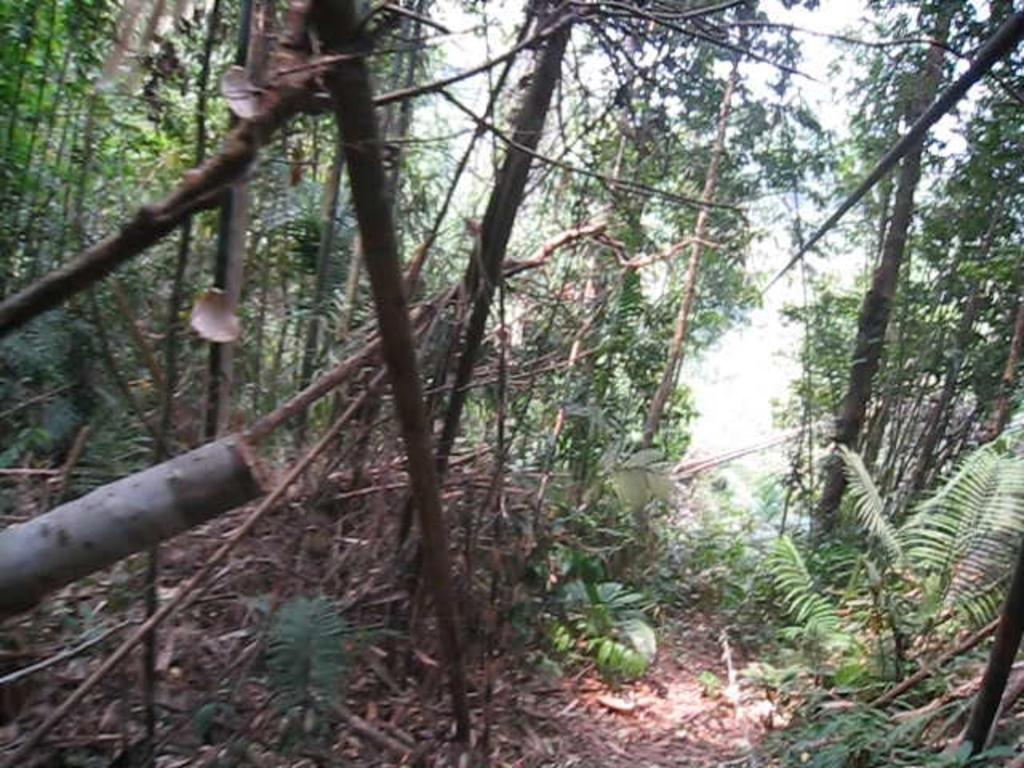What type of vegetation can be seen in the image? There are trees and plants in the image. What is present on the ground in the image? There are leaves on the ground in the image. How many chickens can be seen in the image? There are no chickens present in the image. What type of apparatus is being used by the plants in the image? There is no apparatus present in the image; the plants are growing naturally. 